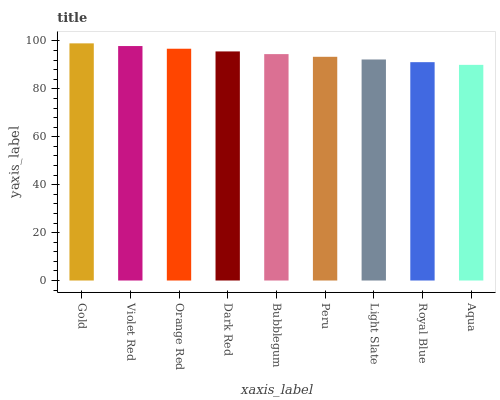Is Aqua the minimum?
Answer yes or no. Yes. Is Gold the maximum?
Answer yes or no. Yes. Is Violet Red the minimum?
Answer yes or no. No. Is Violet Red the maximum?
Answer yes or no. No. Is Gold greater than Violet Red?
Answer yes or no. Yes. Is Violet Red less than Gold?
Answer yes or no. Yes. Is Violet Red greater than Gold?
Answer yes or no. No. Is Gold less than Violet Red?
Answer yes or no. No. Is Bubblegum the high median?
Answer yes or no. Yes. Is Bubblegum the low median?
Answer yes or no. Yes. Is Aqua the high median?
Answer yes or no. No. Is Dark Red the low median?
Answer yes or no. No. 